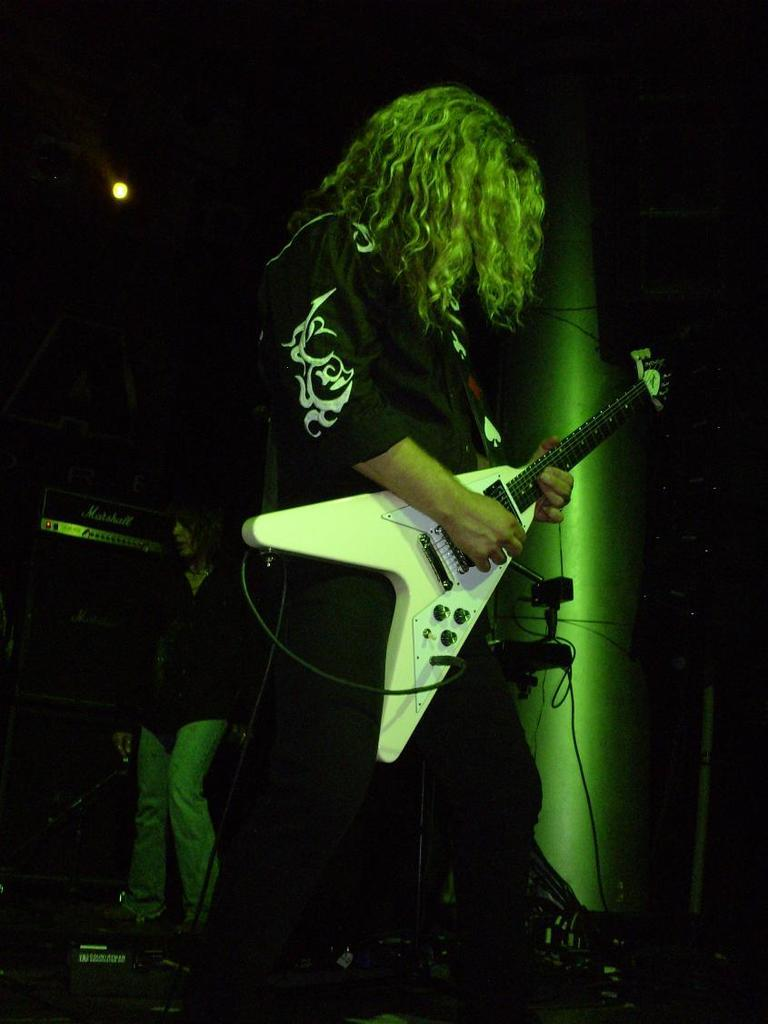What is the main subject of the image? There is a person in the image. What is the person wearing? The person is wearing a black color shirt. What activity is the person engaged in? The person is playing a guitar. What advice does the zebra give to the person playing the guitar in the image? There is no zebra present in the image, so it cannot provide any advice. 